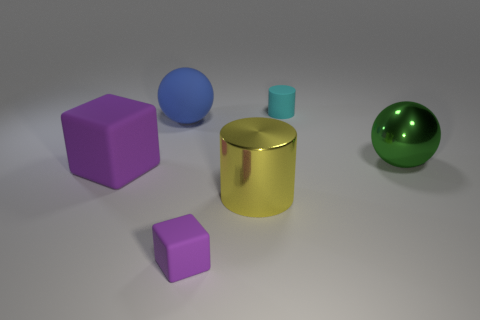What is the material of the tiny cylinder?
Offer a terse response. Rubber. Is the material of the purple object that is in front of the big cylinder the same as the sphere in front of the blue matte object?
Provide a succinct answer. No. There is a purple rubber object that is the same size as the cyan rubber cylinder; what is its shape?
Ensure brevity in your answer.  Cube. What number of other things are there of the same color as the big block?
Make the answer very short. 1. What is the color of the tiny rubber object that is behind the large blue sphere?
Give a very brief answer. Cyan. How many other objects are the same material as the green ball?
Offer a terse response. 1. Are there more metallic objects that are to the right of the tiny cyan matte cylinder than blue matte objects that are in front of the large yellow cylinder?
Offer a very short reply. Yes. There is a big green shiny ball; what number of matte things are left of it?
Give a very brief answer. 4. Does the large purple thing have the same material as the cylinder in front of the large purple rubber object?
Ensure brevity in your answer.  No. Does the blue object have the same material as the large purple object?
Make the answer very short. Yes. 